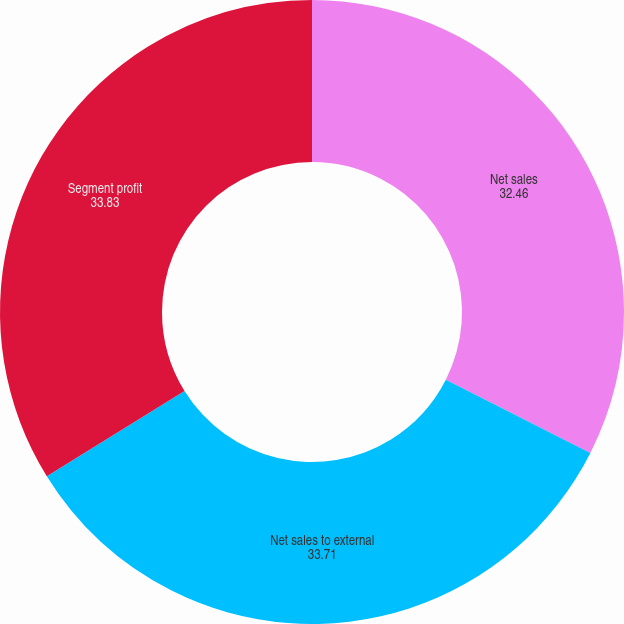Convert chart. <chart><loc_0><loc_0><loc_500><loc_500><pie_chart><fcel>Net sales<fcel>Net sales to external<fcel>Segment profit<nl><fcel>32.46%<fcel>33.71%<fcel>33.83%<nl></chart> 